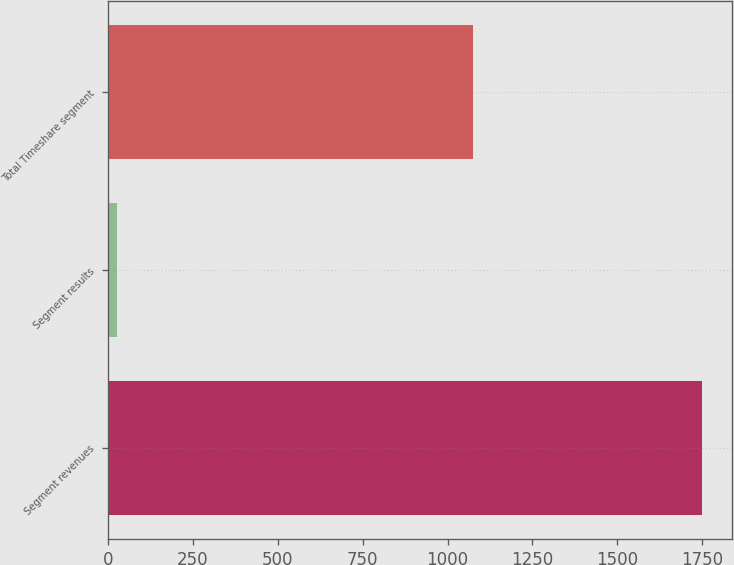Convert chart. <chart><loc_0><loc_0><loc_500><loc_500><bar_chart><fcel>Segment revenues<fcel>Segment results<fcel>Total Timeshare segment<nl><fcel>1750<fcel>28<fcel>1076<nl></chart> 